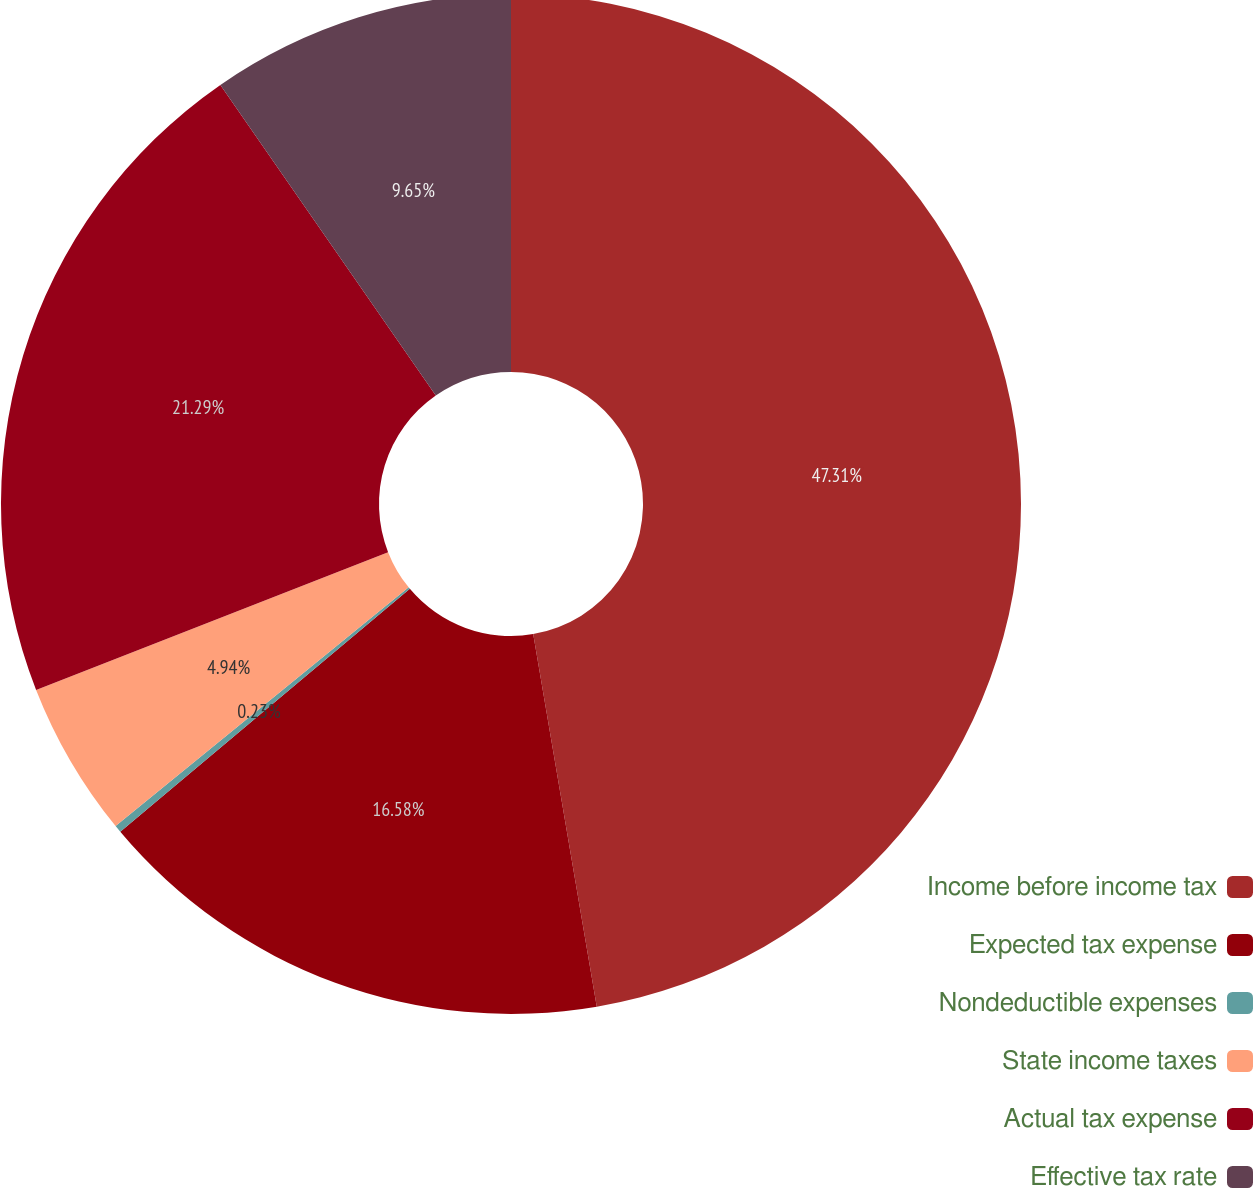Convert chart. <chart><loc_0><loc_0><loc_500><loc_500><pie_chart><fcel>Income before income tax<fcel>Expected tax expense<fcel>Nondeductible expenses<fcel>State income taxes<fcel>Actual tax expense<fcel>Effective tax rate<nl><fcel>47.31%<fcel>16.58%<fcel>0.23%<fcel>4.94%<fcel>21.29%<fcel>9.65%<nl></chart> 